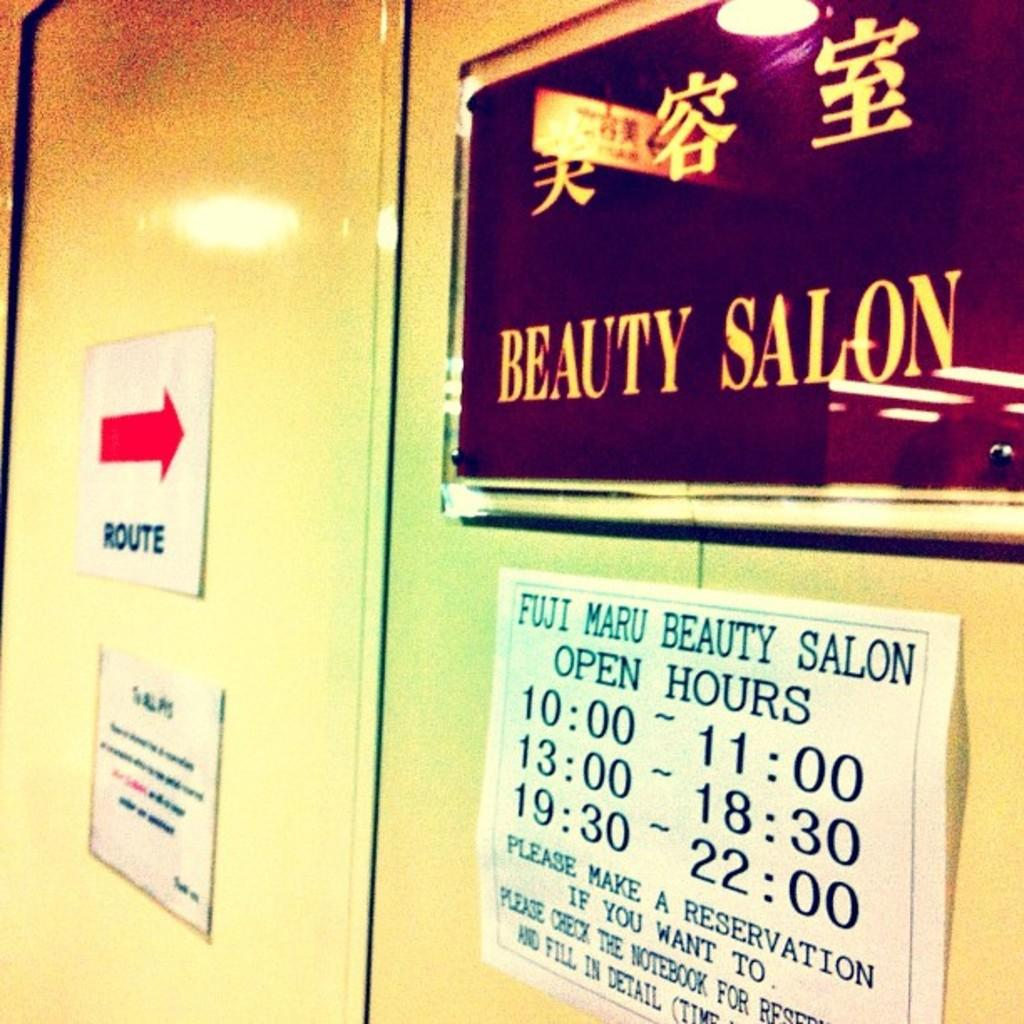<image>
Write a terse but informative summary of the picture. Sign for a beauty salon saying that they are open at 10. 